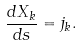<formula> <loc_0><loc_0><loc_500><loc_500>\frac { d X _ { k } } { d s } = j _ { k } .</formula> 